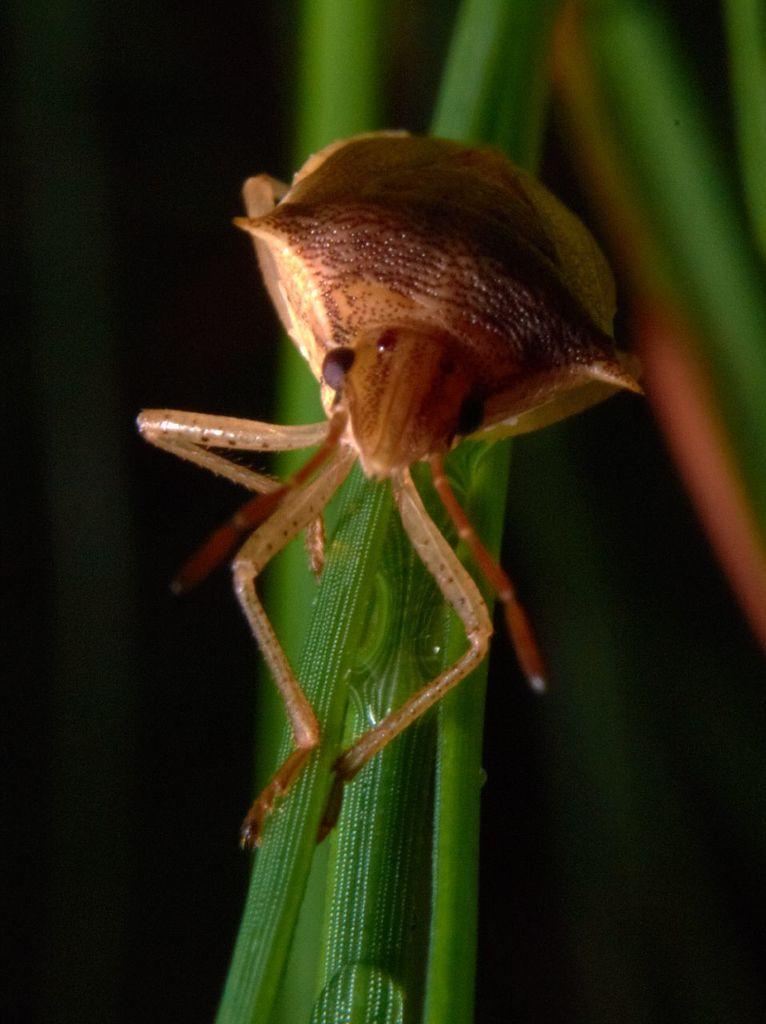Could you give a brief overview of what you see in this image? In this image I can see an insect is on the leaf. In the background of the image it is blurry. 